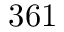Convert formula to latex. <formula><loc_0><loc_0><loc_500><loc_500>3 6 1</formula> 